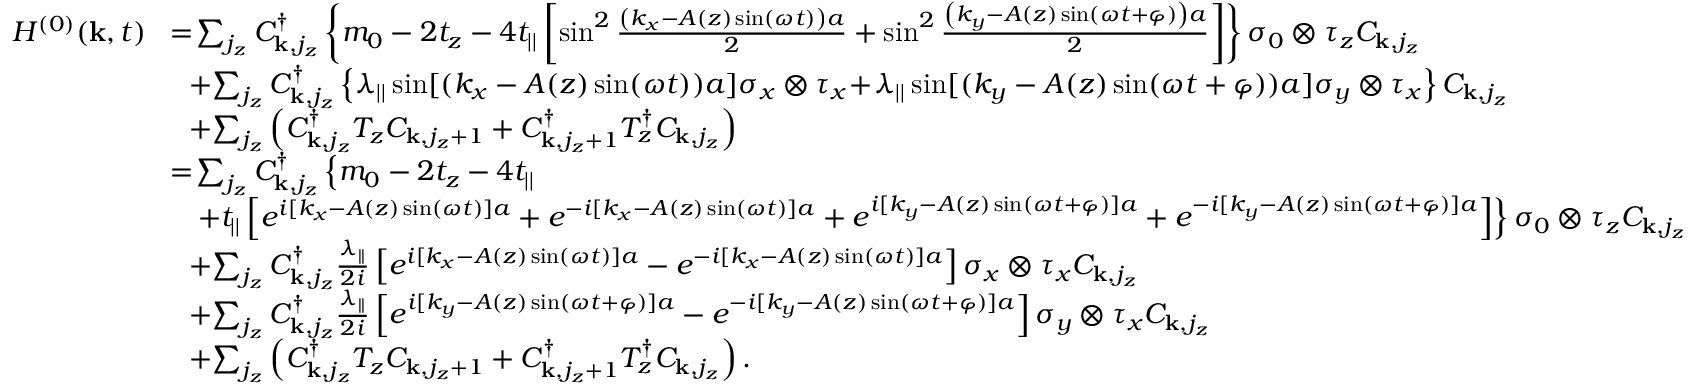<formula> <loc_0><loc_0><loc_500><loc_500>\begin{array} { r l } { H ^ { ( 0 ) } ( { k } , t ) } & { \, = \, \sum _ { j _ { z } } C _ { { k } , j _ { z } } ^ { \dagger } \left \{ m _ { 0 } - 2 t _ { z } - 4 t _ { | | } \left [ \sin ^ { 2 } \frac { \left ( k _ { x } - A ( z ) \sin ( \omega t ) \right ) a } { 2 } + \sin ^ { 2 } \frac { \left ( k _ { y } - A ( z ) \sin ( \omega t + \varphi ) \right ) a } { 2 } \right ] \right \} \sigma _ { 0 } \otimes \tau _ { z } C _ { { k } , j _ { z } } } \\ & { \, + \, \sum _ { j _ { z } } C _ { { k } , j _ { z } } ^ { \dagger } \left \{ \lambda _ { | | } \sin [ ( k _ { x } - A ( z ) \sin ( \omega t ) ) a ] \sigma _ { x } \otimes \tau _ { x } \, + \, \lambda _ { | | } \sin [ ( k _ { y } - A ( z ) \sin ( \omega t + \varphi ) ) a ] \sigma _ { y } \otimes \tau _ { x } \right \} C _ { { k } , j _ { z } } } \\ & { \, + \, \sum _ { j _ { z } } \left ( C _ { { k } , j _ { z } } ^ { \dagger } T _ { z } C _ { { k } , j _ { z } + 1 } + C _ { { k } , j _ { z } + 1 } ^ { \dagger } T _ { z } ^ { \dagger } C _ { { k } , j _ { z } } \right ) } \\ & { \, = \, \sum _ { j _ { z } } C _ { { k } , j _ { z } } ^ { \dagger } \left \{ m _ { 0 } - 2 t _ { z } - 4 t _ { | | } } \\ & { + t _ { | | } \left [ e ^ { i [ k _ { x } - A ( z ) \sin ( \omega t ) ] a } + e ^ { - i [ k _ { x } - A ( z ) \sin ( \omega t ) ] a } + e ^ { i [ k _ { y } - A ( z ) \sin ( \omega t + \varphi ) ] a } + e ^ { - i [ k _ { y } - A ( z ) \sin ( \omega t + \varphi ) ] a } \right ] \right \} \sigma _ { 0 } \otimes \tau _ { z } C _ { { k } , j _ { z } } } \\ & { \, + \, \sum _ { j _ { z } } C _ { { k } , j _ { z } } ^ { \dagger } \frac { \lambda _ { | | } } { 2 i } \left [ e ^ { i [ k _ { x } - A ( z ) \sin ( \omega t ) ] a } - e ^ { - i [ k _ { x } - A ( z ) \sin ( \omega t ) ] a } \right ] \sigma _ { x } \otimes \tau _ { x } C _ { { k } , j _ { z } } } \\ & { \, + \, \sum _ { j _ { z } } C _ { { k } , j _ { z } } ^ { \dagger } \frac { \lambda _ { | | } } { 2 i } \left [ e ^ { i [ k _ { y } - A ( z ) \sin ( \omega t + \varphi ) ] a } - e ^ { - i [ k _ { y } - A ( z ) \sin ( \omega t + \varphi ) ] a } \right ] \sigma _ { y } \otimes \tau _ { x } C _ { { k } , j _ { z } } } \\ & { \, + \, \sum _ { j _ { z } } \left ( C _ { { k } , j _ { z } } ^ { \dagger } T _ { z } C _ { { k } , j _ { z } + 1 } + C _ { { k } , j _ { z } + 1 } ^ { \dagger } T _ { z } ^ { \dagger } C _ { { k } , j _ { z } } \right ) . } \end{array}</formula> 